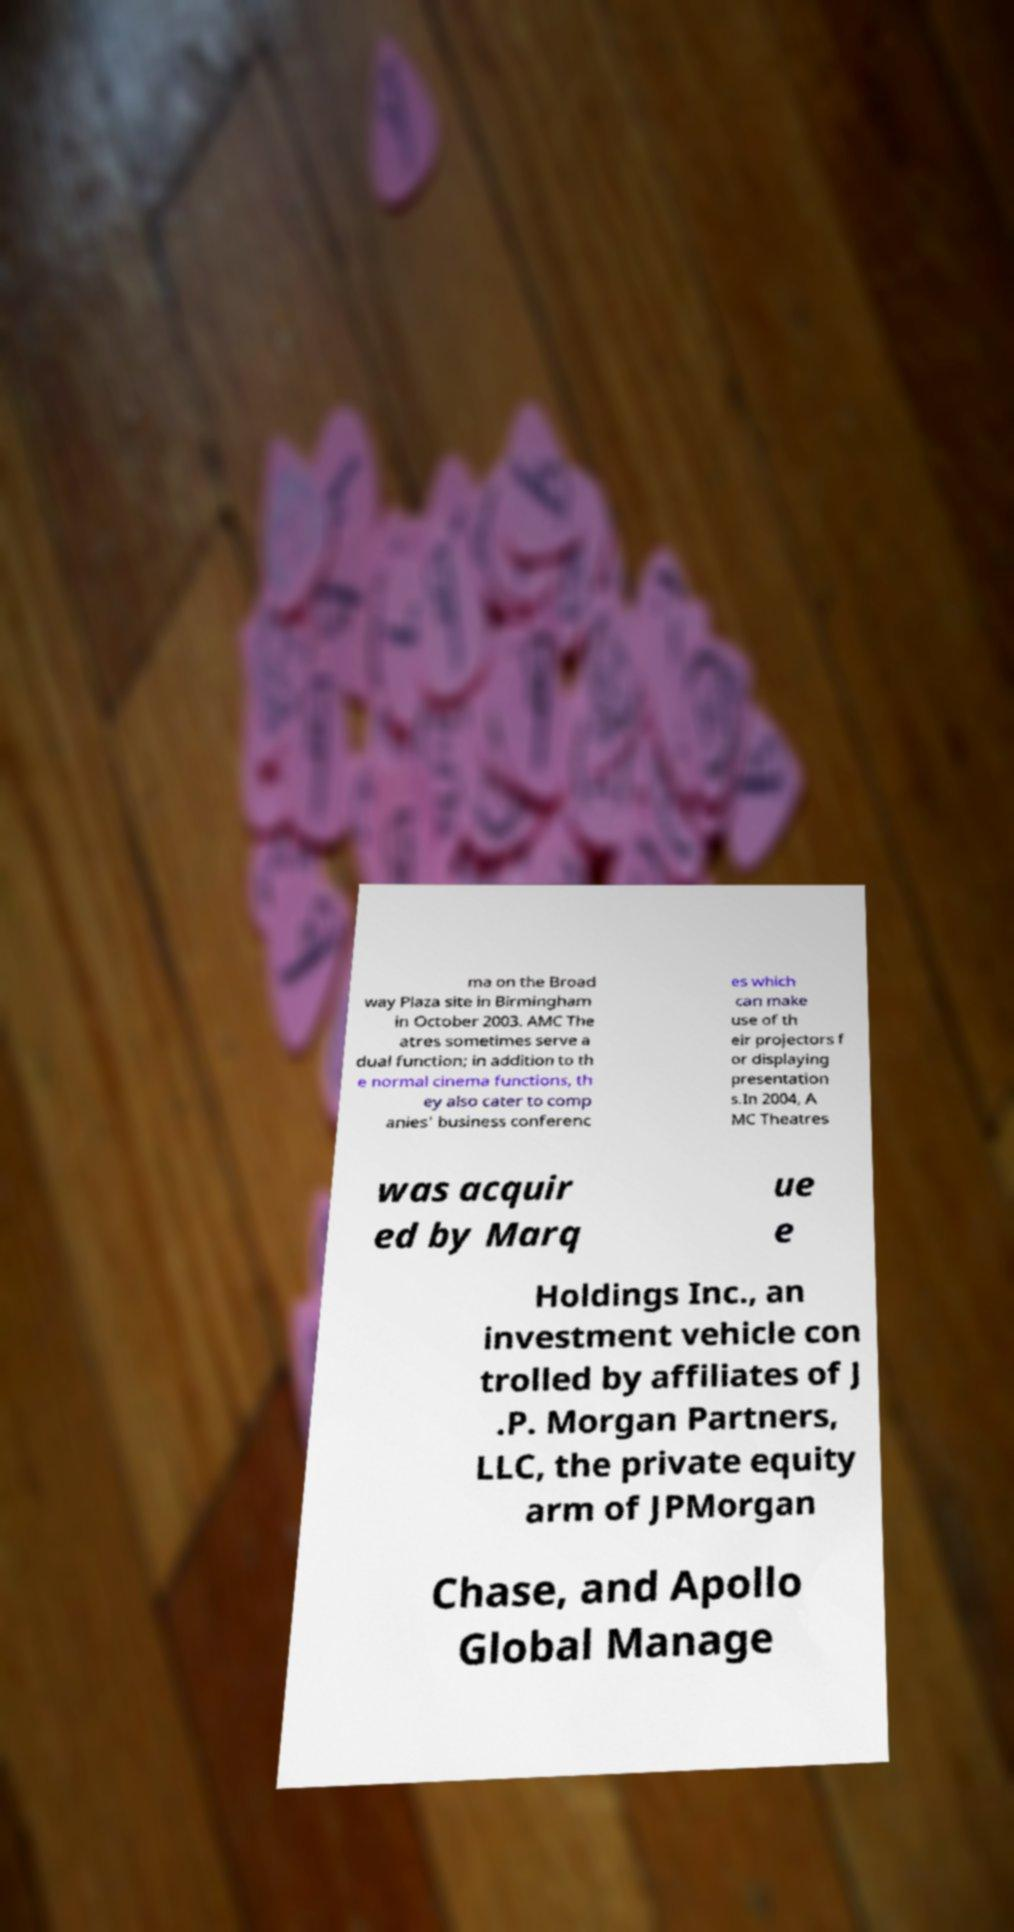Please identify and transcribe the text found in this image. ma on the Broad way Plaza site in Birmingham in October 2003. AMC The atres sometimes serve a dual function; in addition to th e normal cinema functions, th ey also cater to comp anies' business conferenc es which can make use of th eir projectors f or displaying presentation s.In 2004, A MC Theatres was acquir ed by Marq ue e Holdings Inc., an investment vehicle con trolled by affiliates of J .P. Morgan Partners, LLC, the private equity arm of JPMorgan Chase, and Apollo Global Manage 